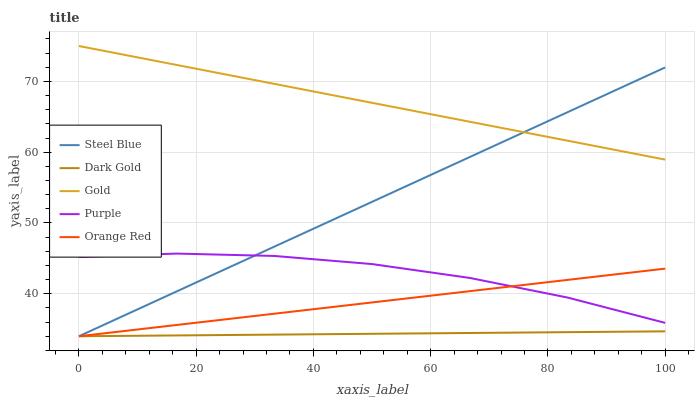Does Dark Gold have the minimum area under the curve?
Answer yes or no. Yes. Does Gold have the maximum area under the curve?
Answer yes or no. Yes. Does Orange Red have the minimum area under the curve?
Answer yes or no. No. Does Orange Red have the maximum area under the curve?
Answer yes or no. No. Is Dark Gold the smoothest?
Answer yes or no. Yes. Is Purple the roughest?
Answer yes or no. Yes. Is Orange Red the smoothest?
Answer yes or no. No. Is Orange Red the roughest?
Answer yes or no. No. Does Orange Red have the lowest value?
Answer yes or no. Yes. Does Gold have the lowest value?
Answer yes or no. No. Does Gold have the highest value?
Answer yes or no. Yes. Does Orange Red have the highest value?
Answer yes or no. No. Is Dark Gold less than Gold?
Answer yes or no. Yes. Is Purple greater than Dark Gold?
Answer yes or no. Yes. Does Dark Gold intersect Steel Blue?
Answer yes or no. Yes. Is Dark Gold less than Steel Blue?
Answer yes or no. No. Is Dark Gold greater than Steel Blue?
Answer yes or no. No. Does Dark Gold intersect Gold?
Answer yes or no. No. 